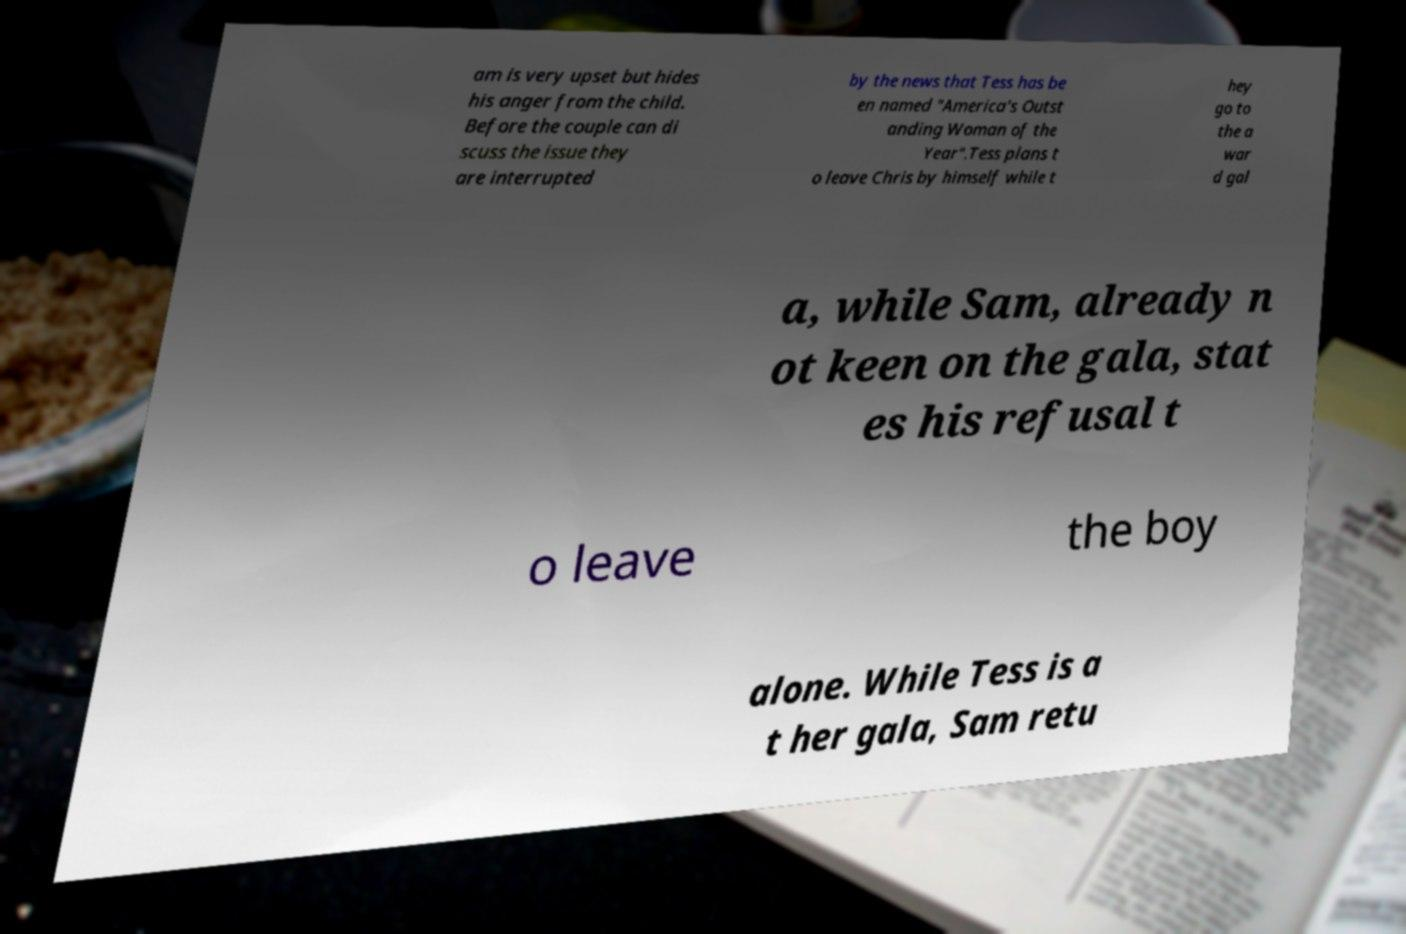Can you read and provide the text displayed in the image?This photo seems to have some interesting text. Can you extract and type it out for me? am is very upset but hides his anger from the child. Before the couple can di scuss the issue they are interrupted by the news that Tess has be en named "America's Outst anding Woman of the Year".Tess plans t o leave Chris by himself while t hey go to the a war d gal a, while Sam, already n ot keen on the gala, stat es his refusal t o leave the boy alone. While Tess is a t her gala, Sam retu 